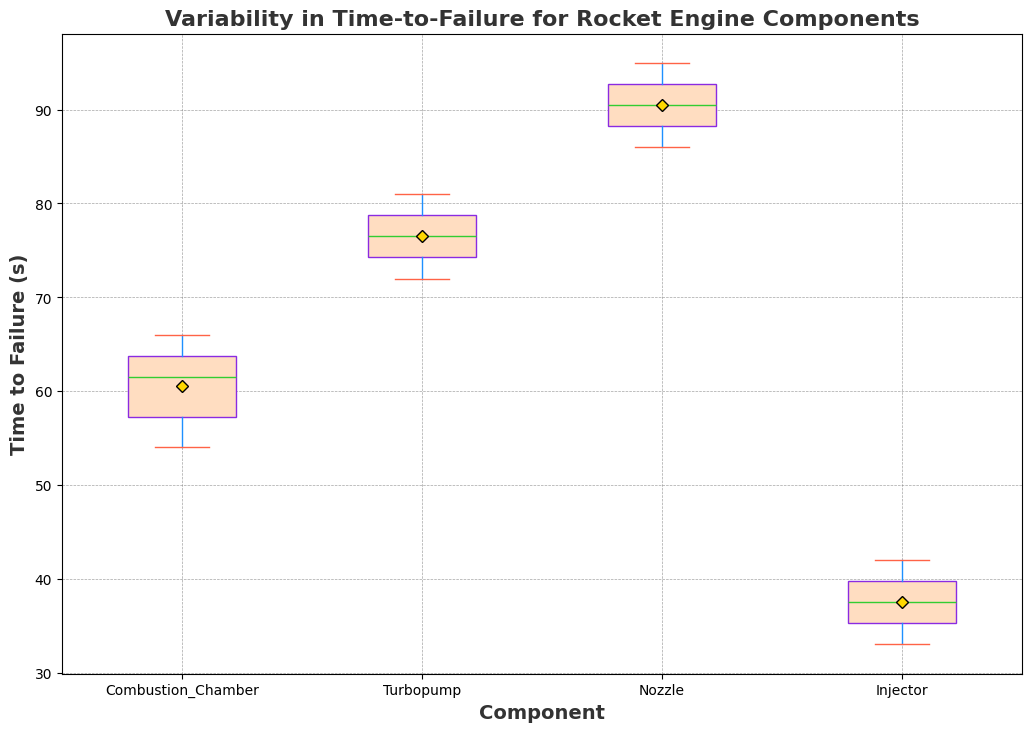What is the median time-to-failure for the Combustion Chamber? To find the median time-to-failure for the Combustion Chamber, look at the middle value of the box plot for the Combustion Chamber.
Answer: 61.5 Which component has the highest median time-to-failure? Compare the median lines in the box plots for all components. The Nozzle has the highest median line.
Answer: Nozzle Which component has the widest range of time-to-failure? The range is the maximum value minus the minimum value, represented by the length of the whiskers in the box plot. For the Injector, the whiskers are the longest indicating the widest range.
Answer: Injector What are the interquartile ranges (IQR) for the Nozzle and Turbopump? The IQR is the difference between the third quartile (Q3) and the first quartile (Q1). For the Nozzle, the IQR is the length of the box from Q3 to Q1. Similarly, for the Turbopump, it is the length of its box.
Answer: Nozzle: 5; Turbopump: 4 How does the variability in time-to-failure for the Injector compare to the Combustion Chamber? Variability can be assessed by looking at the length of the box and whiskers. The Injector has a larger box and longer whiskers compared to the Combustion Chamber, indicating greater variability.
Answer: Injector > Combustion Chamber What is the mean time-to-failure for the Turbopump? The mean is represented by the diamond mark in the box plot for the Turbopump.
Answer: 76 Which component has the most outliers? Outliers are represented by dots outside the whiskers. By counting the outliers for each component, we can see that the Combustion Chamber has the most outliers.
Answer: Combustion Chamber Is there any component that has all its data points within the box plot (no outliers)? Look for a component that has no dots outside its whiskers. The Turbopump has no outliers.
Answer: Turbopump 